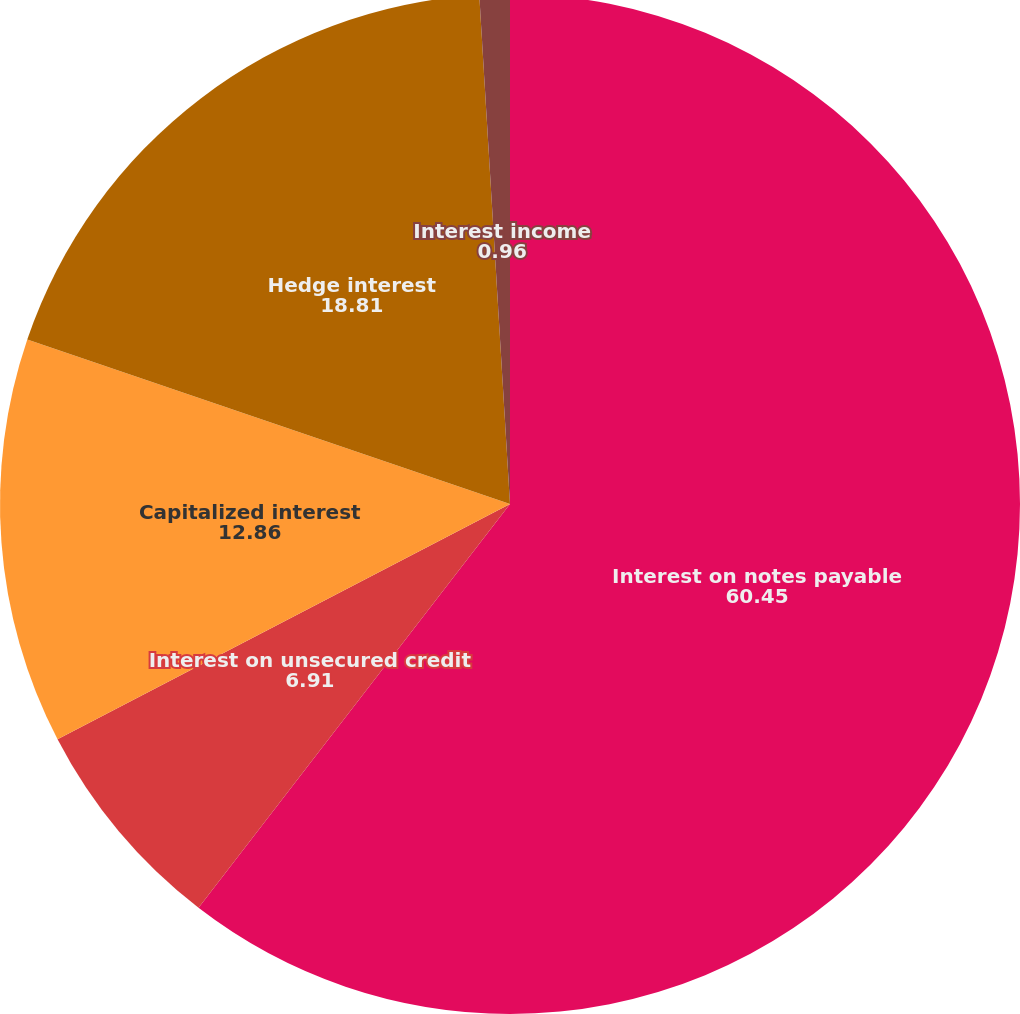<chart> <loc_0><loc_0><loc_500><loc_500><pie_chart><fcel>Interest on notes payable<fcel>Interest on unsecured credit<fcel>Capitalized interest<fcel>Hedge interest<fcel>Interest income<nl><fcel>60.45%<fcel>6.91%<fcel>12.86%<fcel>18.81%<fcel>0.96%<nl></chart> 